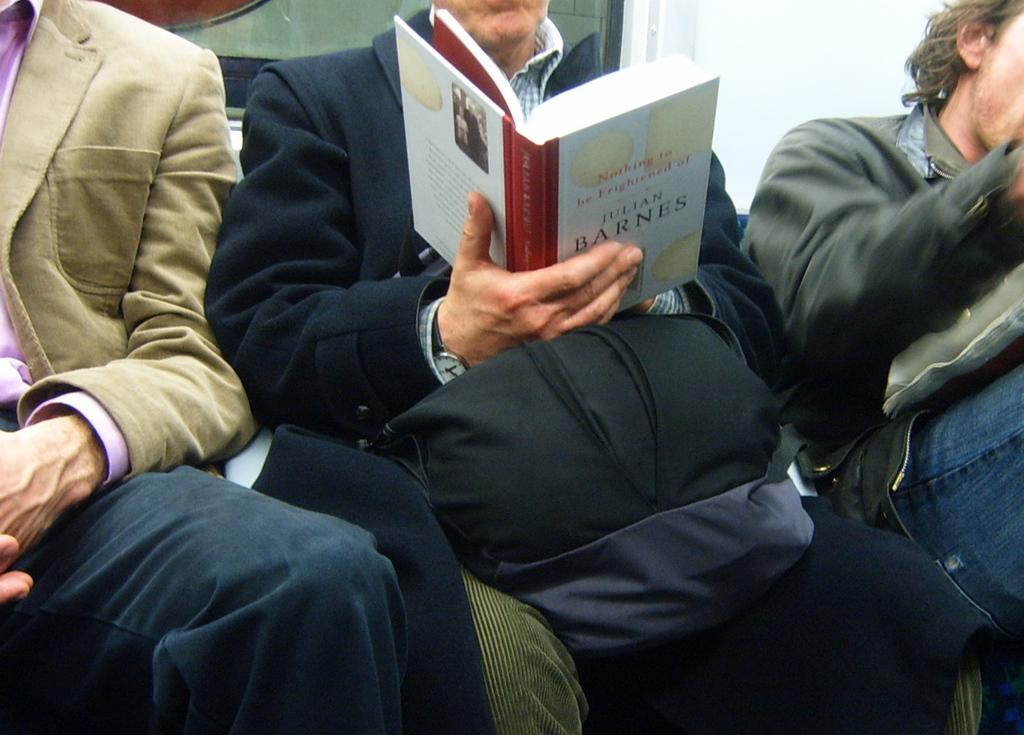What book is that guy reading?
Your answer should be very brief. Nothing to be frightened of. Who wrote the book?
Your answer should be very brief. Julian barnes. 